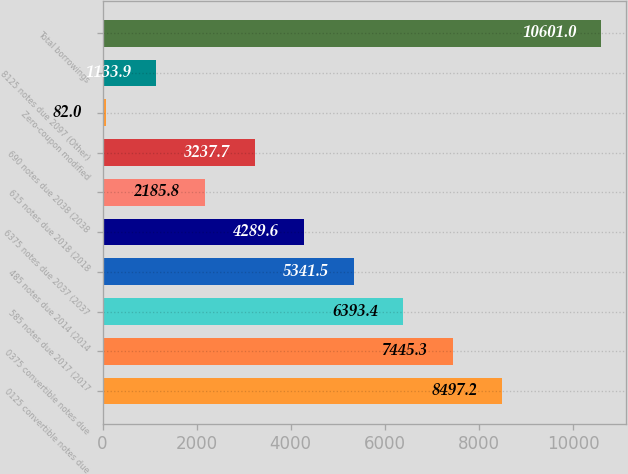Convert chart. <chart><loc_0><loc_0><loc_500><loc_500><bar_chart><fcel>0125 convertible notes due<fcel>0375 convertible notes due<fcel>585 notes due 2017 (2017<fcel>485 notes due 2014 (2014<fcel>6375 notes due 2037 (2037<fcel>615 notes due 2018 (2018<fcel>690 notes due 2038 (2038<fcel>Zero-coupon modified<fcel>8125 notes due 2097 (Other)<fcel>Total borrowings<nl><fcel>8497.2<fcel>7445.3<fcel>6393.4<fcel>5341.5<fcel>4289.6<fcel>2185.8<fcel>3237.7<fcel>82<fcel>1133.9<fcel>10601<nl></chart> 